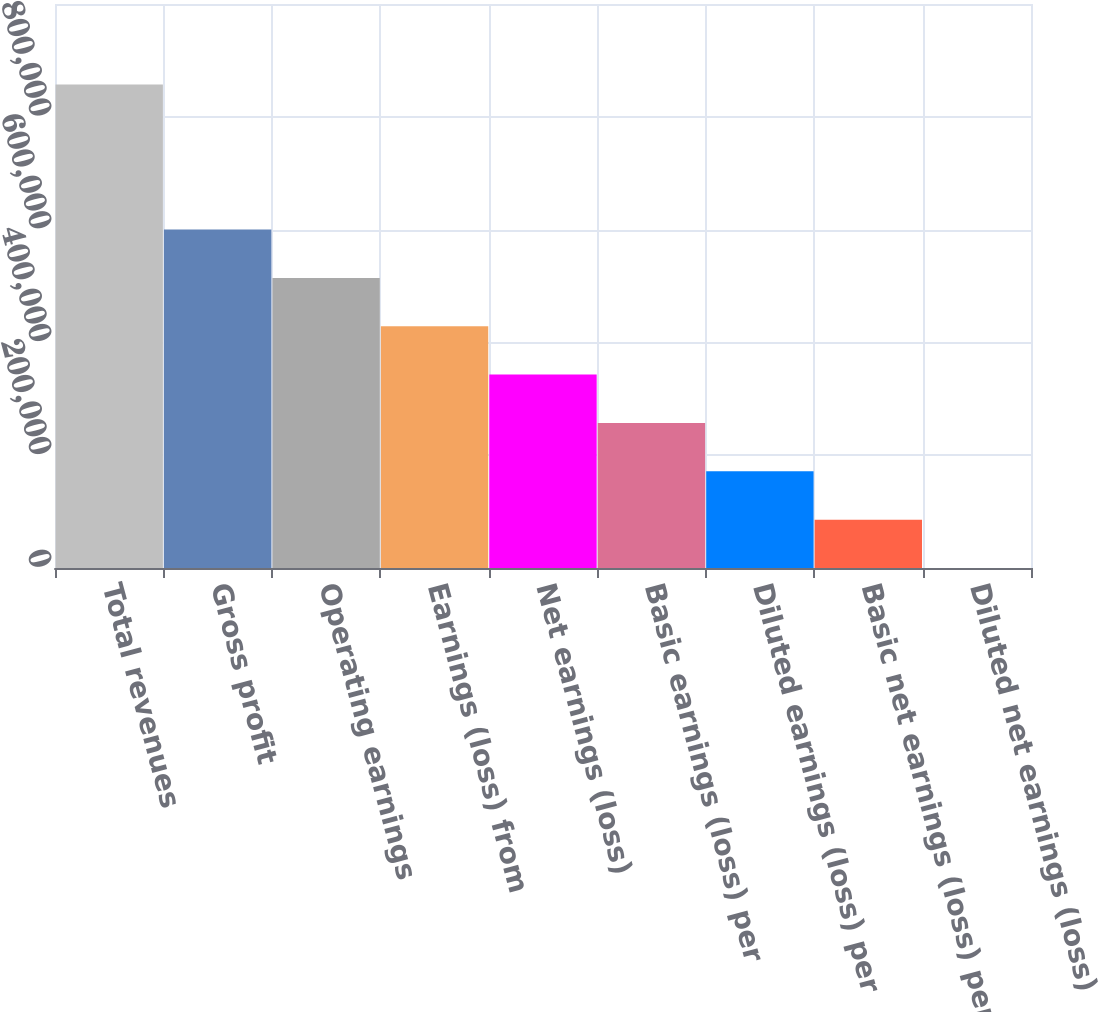Convert chart. <chart><loc_0><loc_0><loc_500><loc_500><bar_chart><fcel>Total revenues<fcel>Gross profit<fcel>Operating earnings<fcel>Earnings (loss) from<fcel>Net earnings (loss)<fcel>Basic earnings (loss) per<fcel>Diluted earnings (loss) per<fcel>Basic net earnings (loss) per<fcel>Diluted net earnings (loss)<nl><fcel>857285<fcel>600100<fcel>514371<fcel>428643<fcel>342914<fcel>257186<fcel>171458<fcel>85729.1<fcel>0.65<nl></chart> 